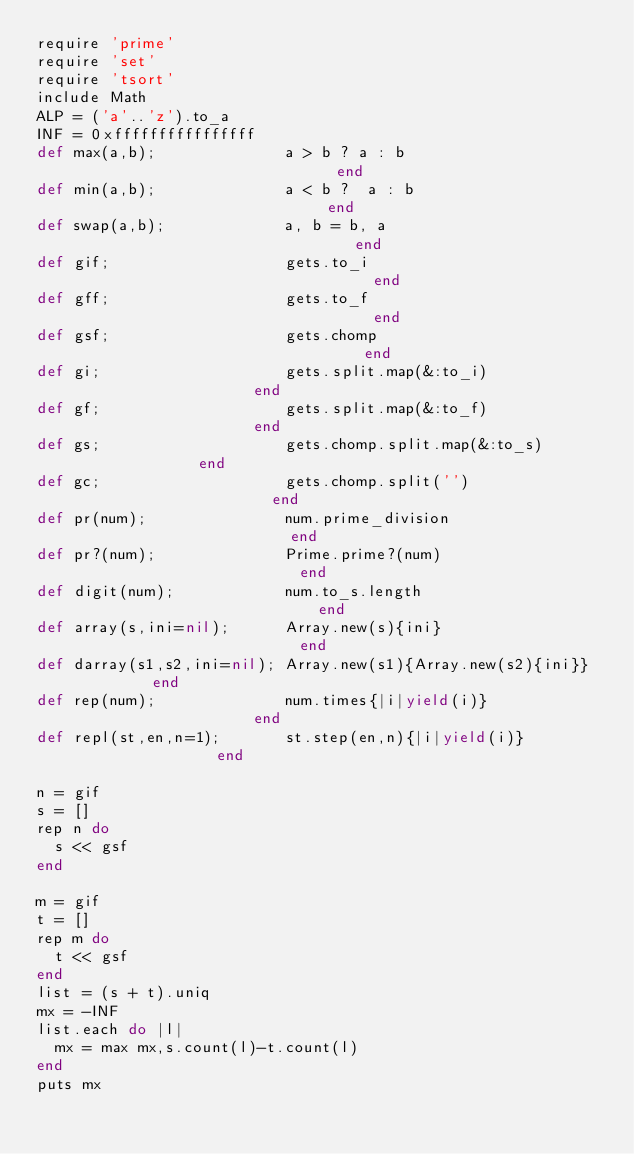Convert code to text. <code><loc_0><loc_0><loc_500><loc_500><_Ruby_>require 'prime'
require 'set'
require 'tsort'
include Math
ALP = ('a'..'z').to_a
INF = 0xffffffffffffffff
def max(a,b);              a > b ? a : b                              end
def min(a,b);              a < b ?  a : b                             end
def swap(a,b);             a, b = b, a                                end
def gif;                   gets.to_i                                  end
def gff;                   gets.to_f                                  end
def gsf;                   gets.chomp                                 end
def gi;                    gets.split.map(&:to_i)                     end
def gf;                    gets.split.map(&:to_f)                     end
def gs;                    gets.chomp.split.map(&:to_s)               end
def gc;                    gets.chomp.split('')                       end
def pr(num);               num.prime_division                         end
def pr?(num);              Prime.prime?(num)                          end
def digit(num);            num.to_s.length                            end
def array(s,ini=nil);      Array.new(s){ini}                          end
def darray(s1,s2,ini=nil); Array.new(s1){Array.new(s2){ini}}          end
def rep(num);              num.times{|i|yield(i)}                     end
def repl(st,en,n=1);       st.step(en,n){|i|yield(i)}                 end

n = gif
s = []
rep n do
  s << gsf
end

m = gif
t = []
rep m do
  t << gsf
end
list = (s + t).uniq
mx = -INF
list.each do |l|
  mx = max mx,s.count(l)-t.count(l)
end
puts mx
</code> 